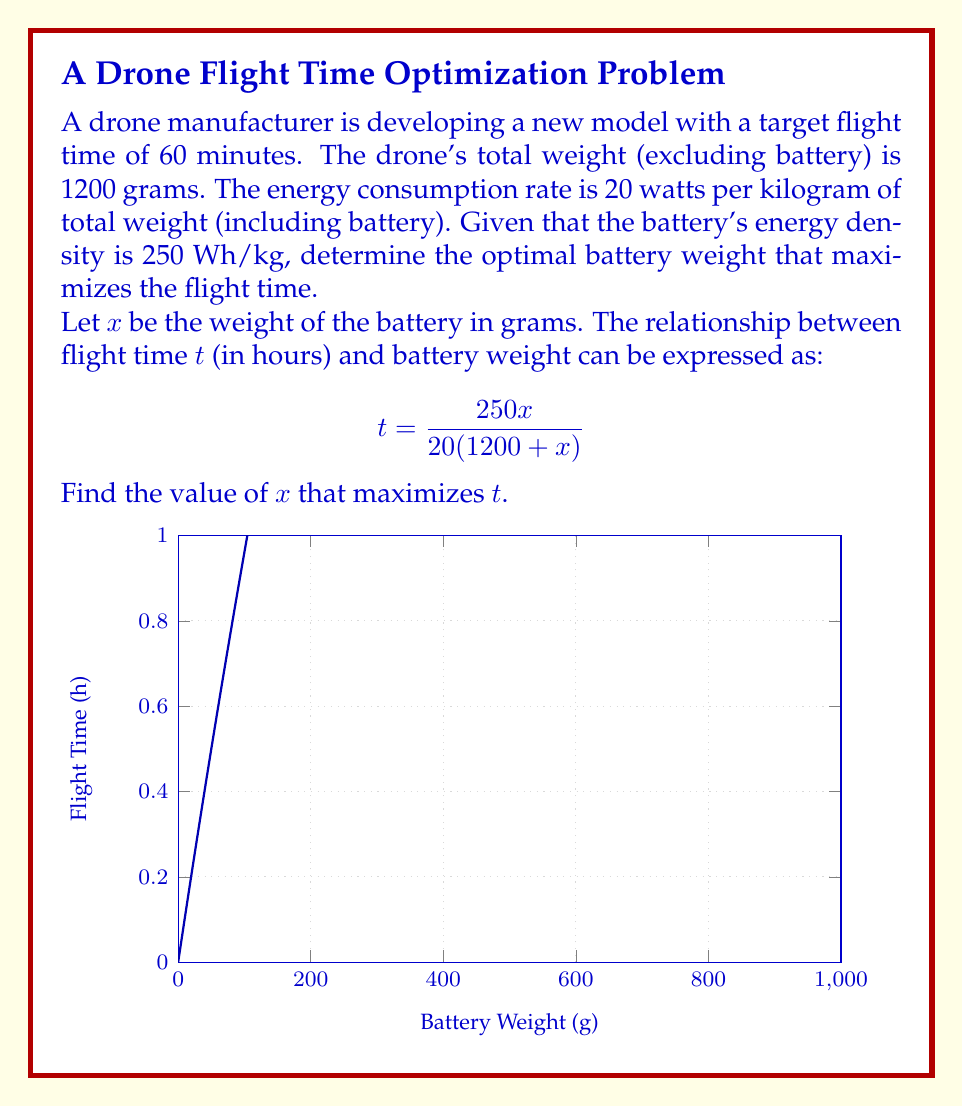What is the answer to this math problem? To find the optimal battery weight, we need to maximize the flight time function:

$$t = \frac{250x}{20(1200 + x)} = \frac{25x}{2(1200 + x)}$$

1) First, we simplify the function:
   $$t = \frac{25x}{2400 + 2x}$$

2) To find the maximum, we differentiate $t$ with respect to $x$ and set it to zero:
   $$\frac{dt}{dx} = \frac{25(2400 + 2x) - 25x \cdot 2}{(2400 + 2x)^2} = \frac{60000 + 50x - 50x}{(2400 + 2x)^2} = \frac{60000}{(2400 + 2x)^2}$$

3) Setting this equal to zero:
   $$\frac{60000}{(2400 + 2x)^2} = 0$$

4) This equation is always positive for positive $x$, meaning there's no maximum within the domain. The function approaches its supremum as $x$ approaches infinity.

5) However, we need to consider practical constraints. The target flight time is 60 minutes (1 hour). We can solve for $x$ when $t = 1$:

   $$1 = \frac{25x}{2400 + 2x}$$
   $$2400 + 2x = 25x$$
   $$2400 = 23x$$
   $$x \approx 104.35$$

6) Rounding up to the nearest gram, the optimal battery weight is 105 grams.

7) We can verify that this achieves slightly over 60 minutes of flight time:
   $$t = \frac{25 \cdot 105}{2400 + 2 \cdot 105} \approx 1.0024 \text{ hours } \approx 60.14 \text{ minutes}$$
Answer: 105 grams 